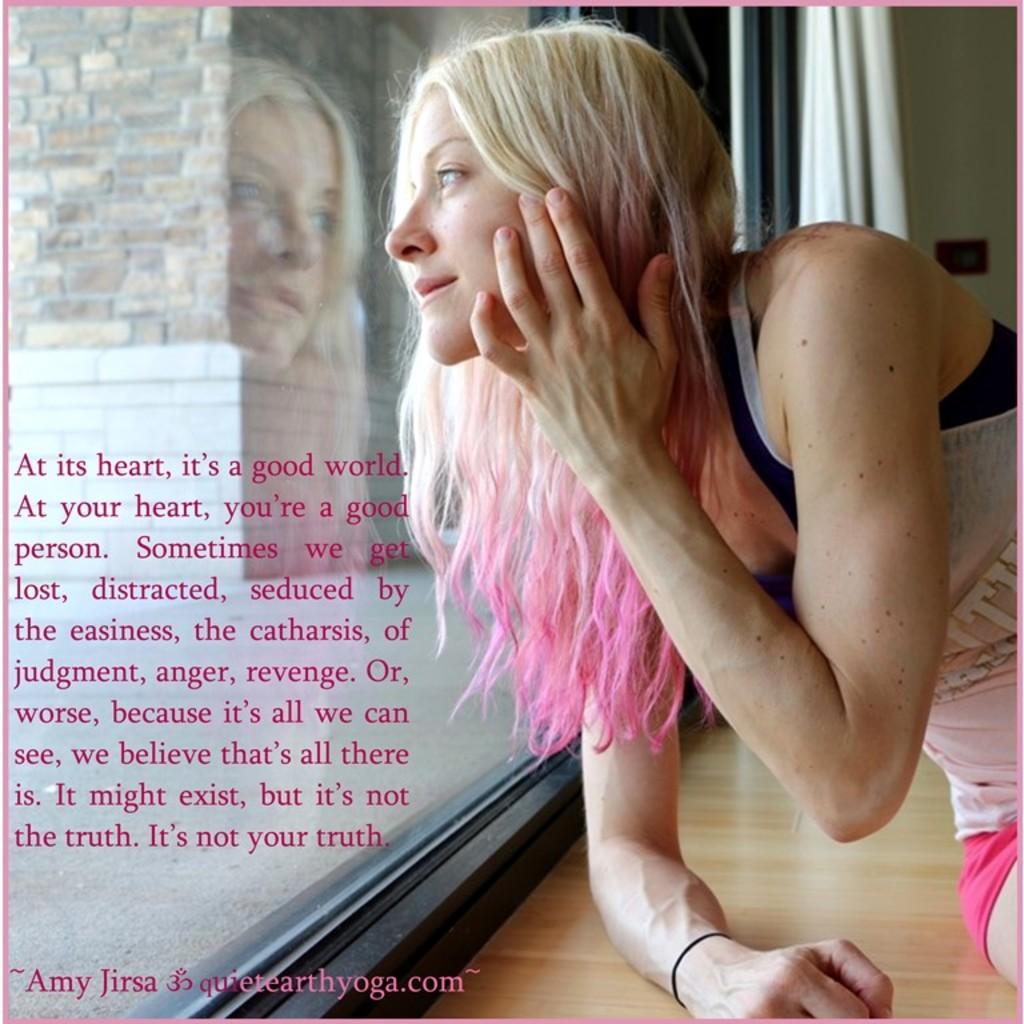In one or two sentences, can you explain what this image depicts? In this image, we can see a person in front of the window. There is a text on the left side of the image. 